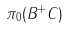<formula> <loc_0><loc_0><loc_500><loc_500>\pi _ { 0 } ( B ^ { + } C )</formula> 